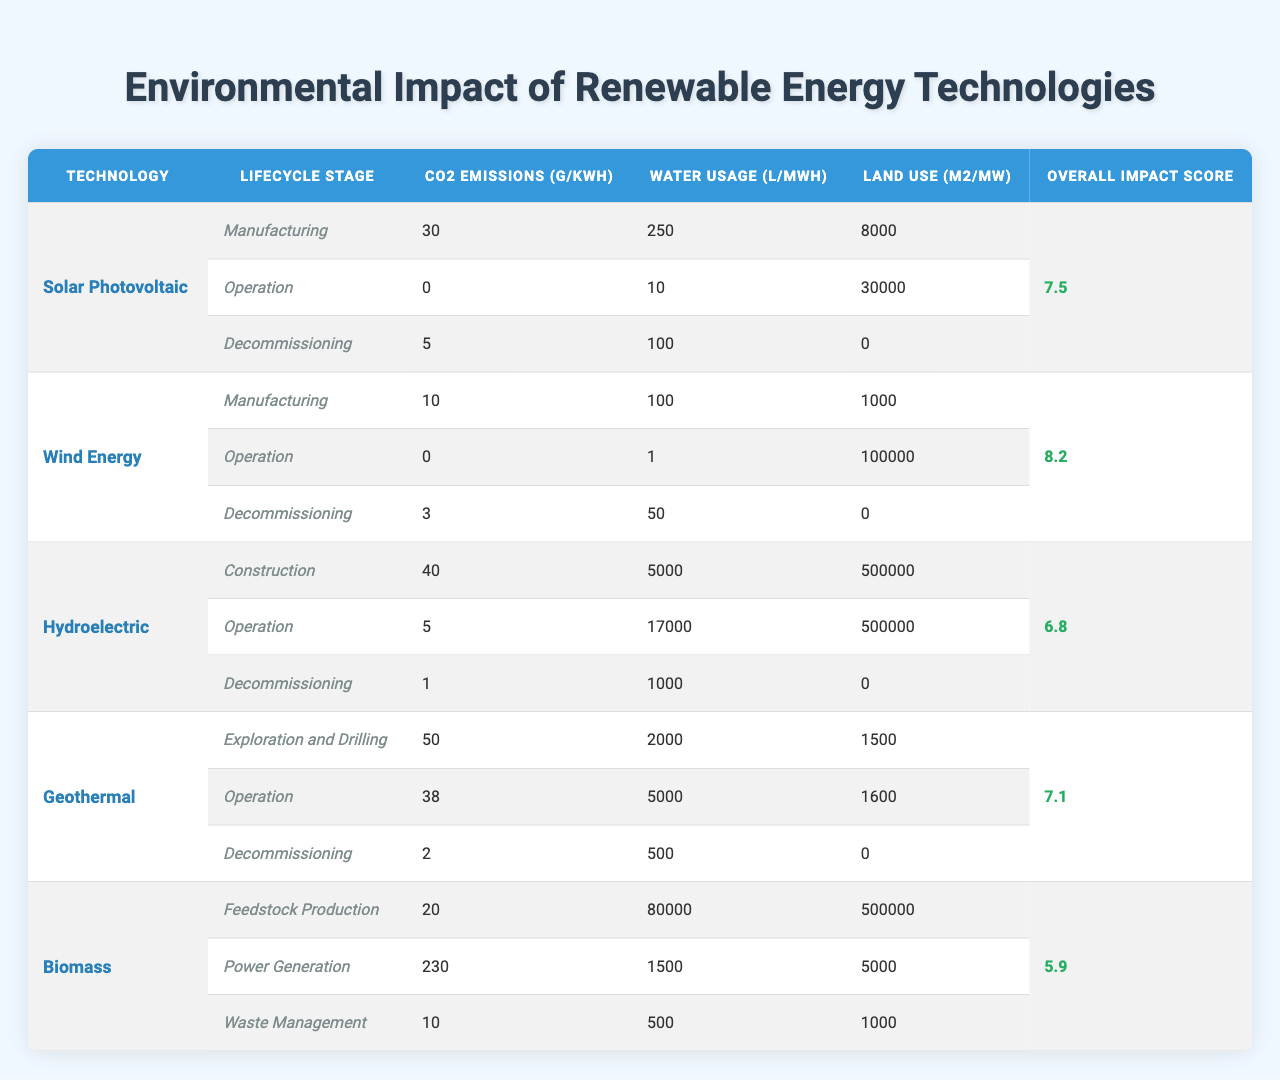What are the CO2 emissions during the operation stage of Solar Photovoltaic technology? The table shows that the CO2 emissions during the operation stage for Solar Photovoltaic technology is 0 g/kWh.
Answer: 0 g/kWh Which renewable energy technology has the highest overall impact score? By comparing the overall impact scores listed in the table, Wind Energy has the highest score at 8.2.
Answer: Wind Energy What is the total water usage for Biomass across all lifecycle stages? The table shows water usage for Biomass as follows: Feedstock Production 80,000 L/MWh, Power Generation 1,500 L/MWh, and Waste Management 500 L/MWh. Adding these values gives 80,000 + 1,500 + 500 = 82,000 L/MWh.
Answer: 82,000 L/MWh During which lifecycle stage does Wind Energy have the lowest CO2 emissions? According to the table, Wind Energy has 0 g/kWh emissions during the operation stage, which is the lowest compared to other stages.
Answer: Operation stage Is it true that Hydroelectric technology has the highest land use during the operation stage? By examining the table, the land use for Hydroelectric during operation is 500,000 m2/MW, and no other technology exceeds this value at the same stage. Thus, this statement is true.
Answer: Yes Calculate the average CO2 emissions during the manufacturing stage across different technologies. The CO2 emissions for each technology in the manufacturing stage are: Solar Photovoltaic 30 g/kWh, Wind Energy 10 g/kWh, Hydroelectric 40 g/kWh, Geothermal 50 g/kWh, and Biomass 20 g/kWh. The average is calculated as follows: (30 + 10 + 40 + 50 + 20) / 5 = 150 / 5 = 30 g/kWh.
Answer: 30 g/kWh What is the water usage during decommissioning for Geothermal technology? The table states that the water usage during decommissioning for Geothermal technology is 500 L/MWh.
Answer: 500 L/MWh If you compare the CO2 emissions between the operation stages of Solar Photovoltaic and Hydroelectric, which has lower emissions? Looking at the table, Solar Photovoltaic has 0 g/kWh emissions, while Hydroelectric has 5 g/kWh. Since 0 < 5, Solar Photovoltaic has lower emissions during the operation stage.
Answer: Solar Photovoltaic What is the land use in square meters during the decommissioning stage for Biomass technology? According to the table, the land use during the decommissioning stage for Biomass technology is 1,000 m2/MW.
Answer: 1,000 m2/MW Determine if the total water usage during the operation stage is higher in Geothermal than in Biomass. The water usage during operation for Geothermal is 5,000 L/MWh, while for Biomass, it is 1,500 L/MWh. Comparing these values shows that 5,000 > 1,500, so Geothermal has higher water usage.
Answer: Yes 